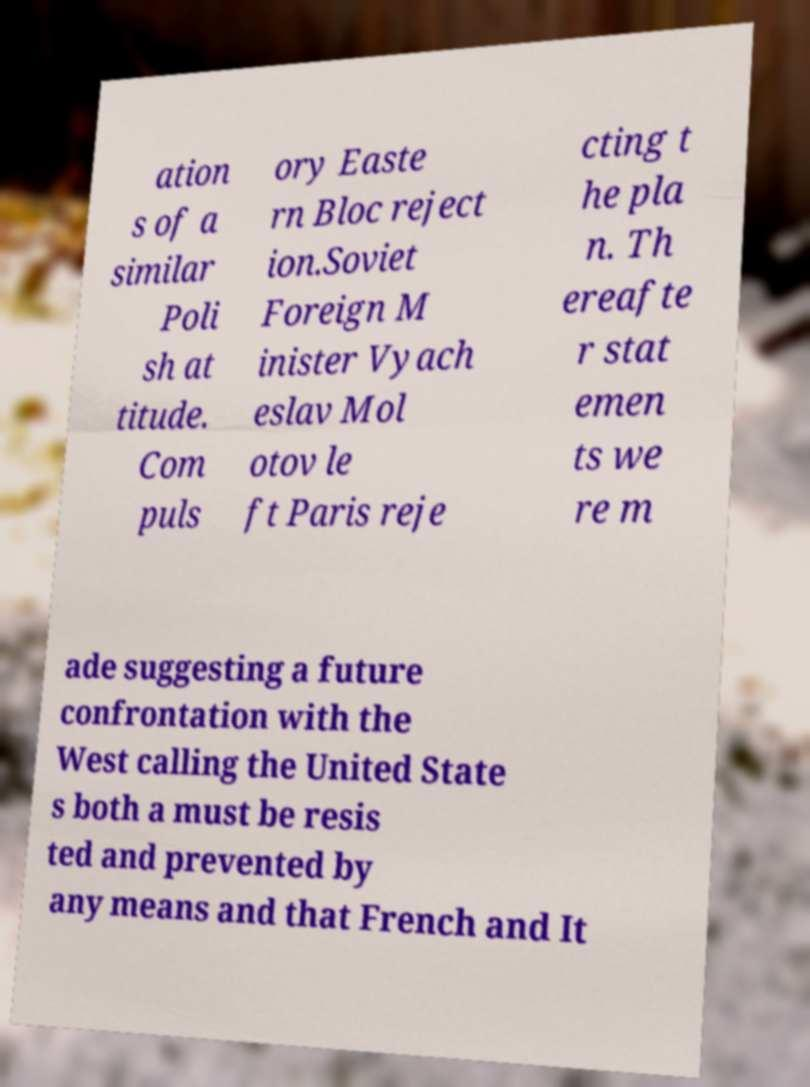Could you assist in decoding the text presented in this image and type it out clearly? ation s of a similar Poli sh at titude. Com puls ory Easte rn Bloc reject ion.Soviet Foreign M inister Vyach eslav Mol otov le ft Paris reje cting t he pla n. Th ereafte r stat emen ts we re m ade suggesting a future confrontation with the West calling the United State s both a must be resis ted and prevented by any means and that French and It 